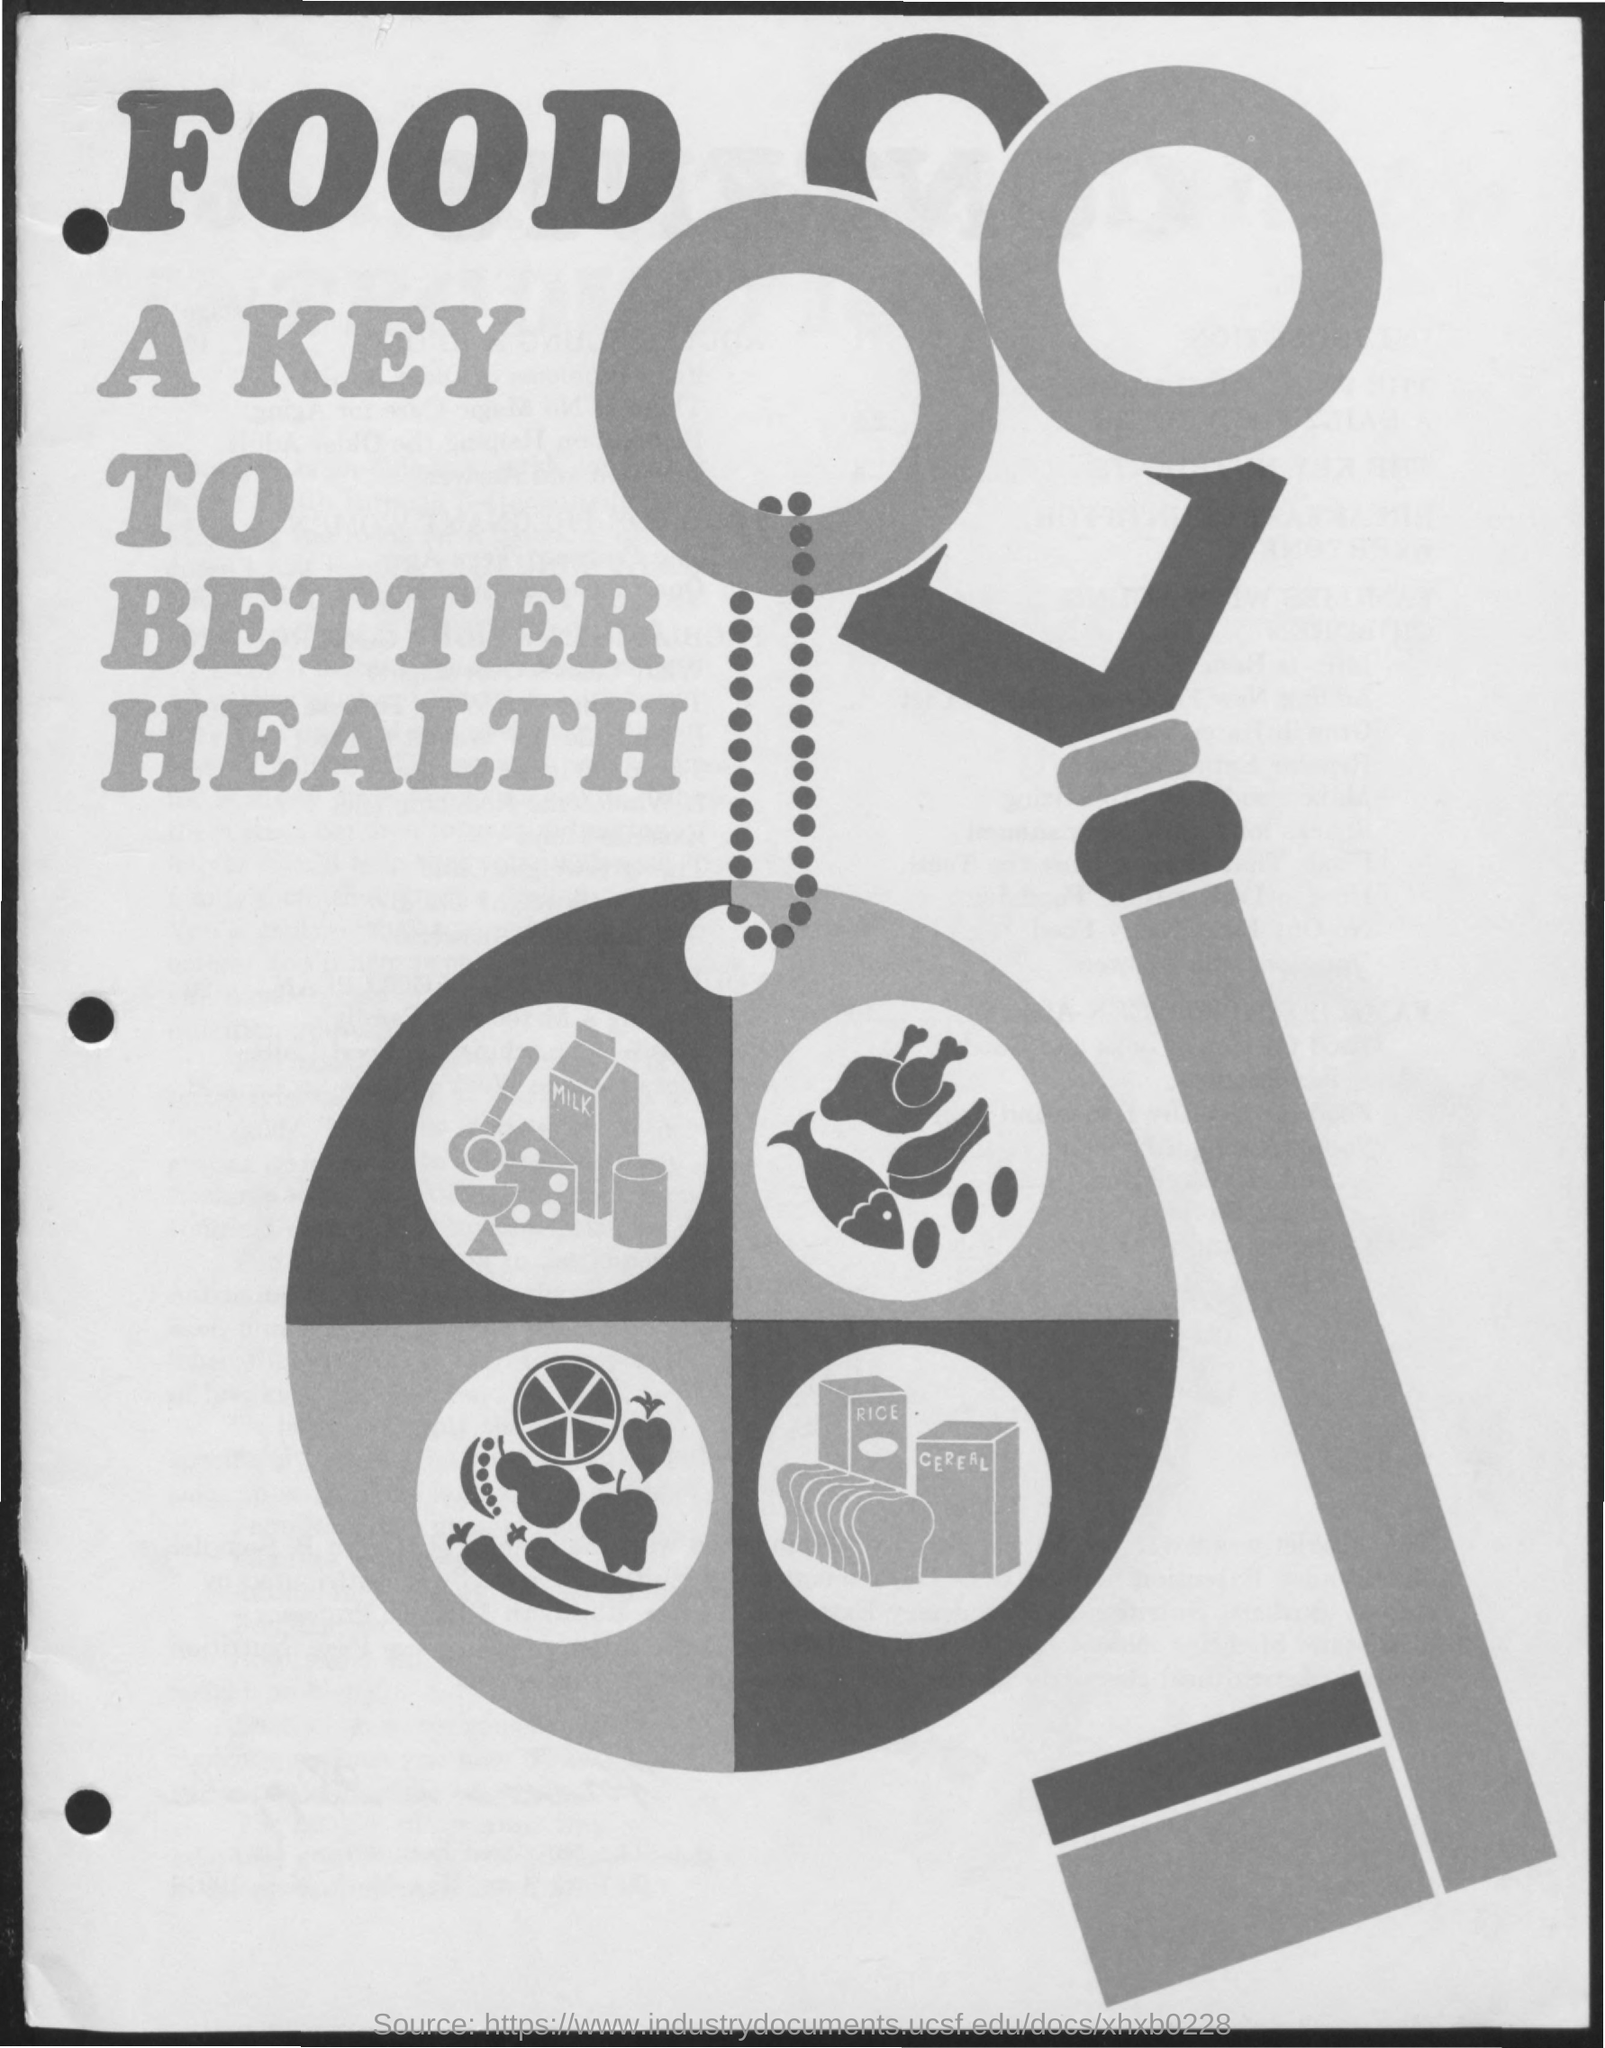What is the title of the document?
Offer a terse response. Food a key to better health. 